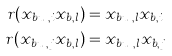<formula> <loc_0><loc_0><loc_500><loc_500>r ( x _ { b u _ { l } , i } x _ { b , l } ) & = x _ { b u _ { i } , l } x _ { b , i } \\ r ( x _ { b u _ { l } , j } x _ { b , l } ) & = x _ { b u _ { j } , l } x _ { b , j } \\</formula> 